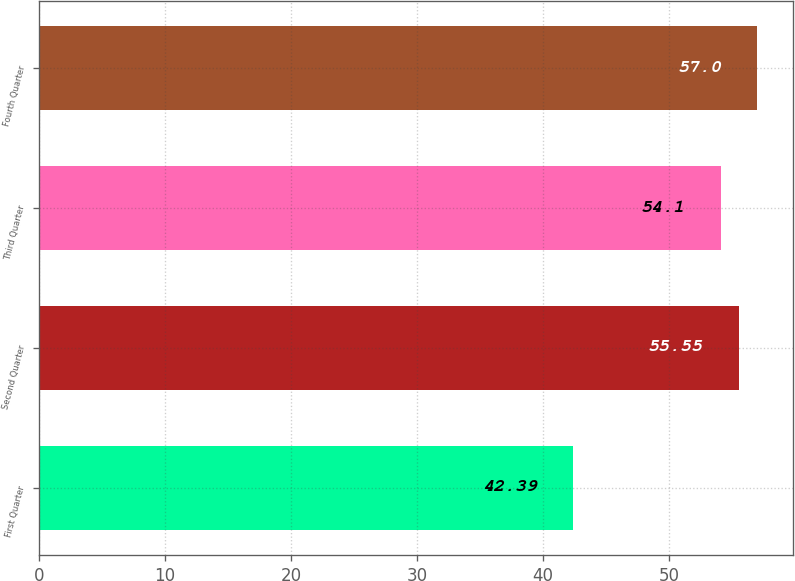Convert chart. <chart><loc_0><loc_0><loc_500><loc_500><bar_chart><fcel>First Quarter<fcel>Second Quarter<fcel>Third Quarter<fcel>Fourth Quarter<nl><fcel>42.39<fcel>55.55<fcel>54.1<fcel>57<nl></chart> 